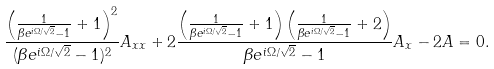<formula> <loc_0><loc_0><loc_500><loc_500>\frac { \left ( \frac { 1 } { \beta e ^ { i \Omega / \sqrt { 2 } } - 1 } + 1 \right ) ^ { 2 } } { ( \beta e ^ { i \Omega / \sqrt { 2 } } - 1 ) ^ { 2 } } A _ { x x } + 2 \frac { \left ( \frac { 1 } { \beta e ^ { i \Omega / \sqrt { 2 } } - 1 } + 1 \right ) \left ( \frac { 1 } { \beta e ^ { i \Omega / \sqrt { 2 } } - 1 } + 2 \right ) } { \beta e ^ { i \Omega / \sqrt { 2 } } - 1 } A _ { x } - 2 A = 0 .</formula> 